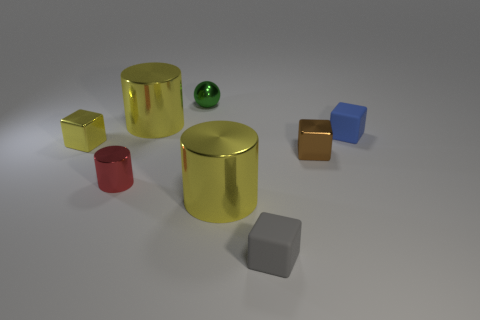Could you speculate about the setting or purpose of these objects, perhaps why they are arranged this way? The arrangement of these objects appears quite deliberate, possibly set up for an educational purpose to illustrate differences in colors, materials, and geometrical shapes. Each object's reflective surface and the clean, simple background might suggest a controlled environment, like a photography studio or a visual demonstration for a physics or art lesson about light and reflections. 